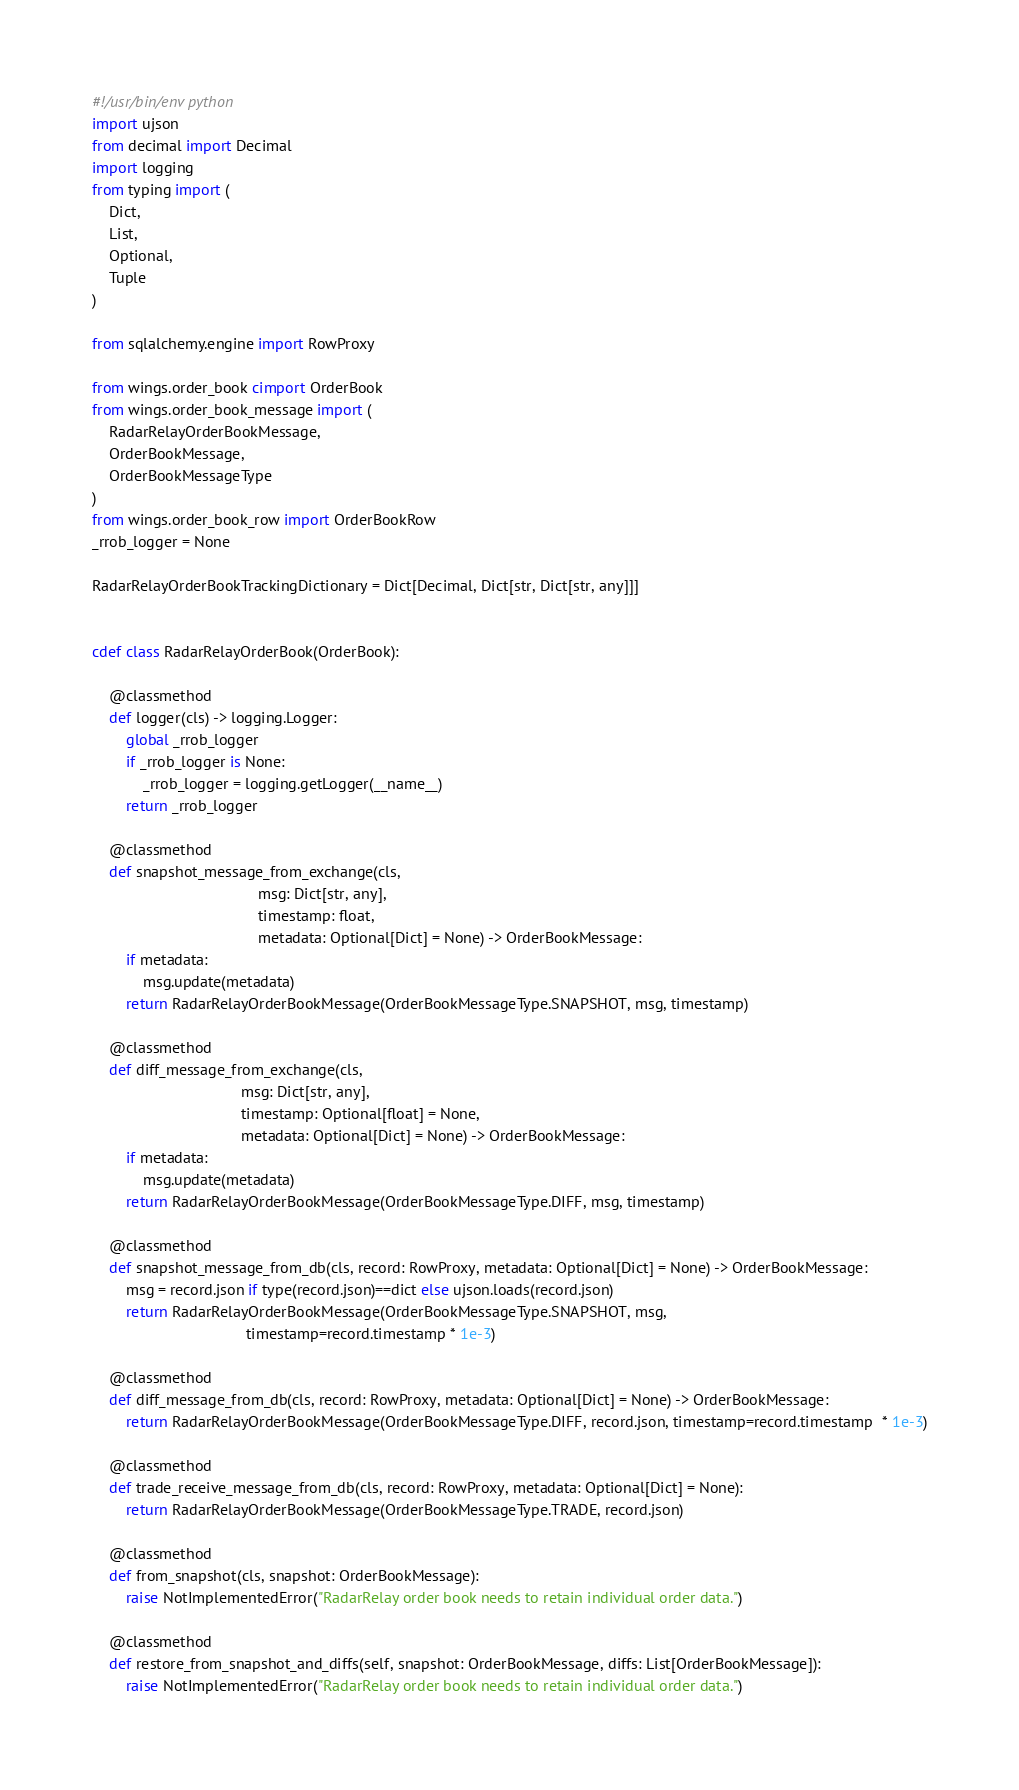Convert code to text. <code><loc_0><loc_0><loc_500><loc_500><_Cython_>#!/usr/bin/env python
import ujson
from decimal import Decimal
import logging
from typing import (
    Dict,
    List,
    Optional,
    Tuple
)

from sqlalchemy.engine import RowProxy

from wings.order_book cimport OrderBook
from wings.order_book_message import (
    RadarRelayOrderBookMessage,
    OrderBookMessage,
    OrderBookMessageType
)
from wings.order_book_row import OrderBookRow
_rrob_logger = None

RadarRelayOrderBookTrackingDictionary = Dict[Decimal, Dict[str, Dict[str, any]]]


cdef class RadarRelayOrderBook(OrderBook):

    @classmethod
    def logger(cls) -> logging.Logger:
        global _rrob_logger
        if _rrob_logger is None:
            _rrob_logger = logging.getLogger(__name__)
        return _rrob_logger

    @classmethod
    def snapshot_message_from_exchange(cls,
                                       msg: Dict[str, any],
                                       timestamp: float,
                                       metadata: Optional[Dict] = None) -> OrderBookMessage:
        if metadata:
            msg.update(metadata)
        return RadarRelayOrderBookMessage(OrderBookMessageType.SNAPSHOT, msg, timestamp)

    @classmethod
    def diff_message_from_exchange(cls,
                                   msg: Dict[str, any],
                                   timestamp: Optional[float] = None,
                                   metadata: Optional[Dict] = None) -> OrderBookMessage:
        if metadata:
            msg.update(metadata)
        return RadarRelayOrderBookMessage(OrderBookMessageType.DIFF, msg, timestamp)

    @classmethod
    def snapshot_message_from_db(cls, record: RowProxy, metadata: Optional[Dict] = None) -> OrderBookMessage:
        msg = record.json if type(record.json)==dict else ujson.loads(record.json)
        return RadarRelayOrderBookMessage(OrderBookMessageType.SNAPSHOT, msg,
                                    timestamp=record.timestamp * 1e-3)

    @classmethod
    def diff_message_from_db(cls, record: RowProxy, metadata: Optional[Dict] = None) -> OrderBookMessage:
        return RadarRelayOrderBookMessage(OrderBookMessageType.DIFF, record.json, timestamp=record.timestamp  * 1e-3)

    @classmethod
    def trade_receive_message_from_db(cls, record: RowProxy, metadata: Optional[Dict] = None):
        return RadarRelayOrderBookMessage(OrderBookMessageType.TRADE, record.json)

    @classmethod
    def from_snapshot(cls, snapshot: OrderBookMessage):
        raise NotImplementedError("RadarRelay order book needs to retain individual order data.")

    @classmethod
    def restore_from_snapshot_and_diffs(self, snapshot: OrderBookMessage, diffs: List[OrderBookMessage]):
        raise NotImplementedError("RadarRelay order book needs to retain individual order data.")
</code> 